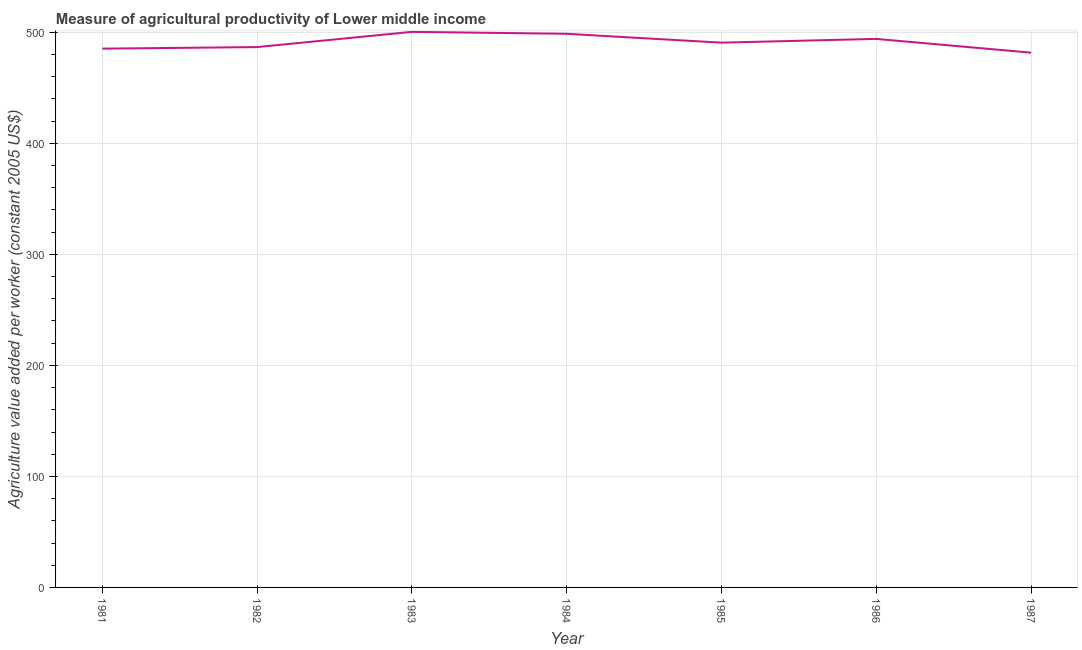What is the agriculture value added per worker in 1982?
Ensure brevity in your answer.  486.74. Across all years, what is the maximum agriculture value added per worker?
Provide a succinct answer. 500.44. Across all years, what is the minimum agriculture value added per worker?
Ensure brevity in your answer.  481.7. What is the sum of the agriculture value added per worker?
Provide a succinct answer. 3437.73. What is the difference between the agriculture value added per worker in 1984 and 1987?
Provide a short and direct response. 17. What is the average agriculture value added per worker per year?
Your answer should be compact. 491.1. What is the median agriculture value added per worker?
Provide a short and direct response. 490.72. In how many years, is the agriculture value added per worker greater than 460 US$?
Offer a terse response. 7. What is the ratio of the agriculture value added per worker in 1981 to that in 1982?
Your response must be concise. 1. Is the difference between the agriculture value added per worker in 1985 and 1987 greater than the difference between any two years?
Ensure brevity in your answer.  No. What is the difference between the highest and the second highest agriculture value added per worker?
Provide a succinct answer. 1.74. What is the difference between the highest and the lowest agriculture value added per worker?
Make the answer very short. 18.74. In how many years, is the agriculture value added per worker greater than the average agriculture value added per worker taken over all years?
Keep it short and to the point. 3. Does the agriculture value added per worker monotonically increase over the years?
Offer a terse response. No. How many lines are there?
Offer a terse response. 1. How many years are there in the graph?
Give a very brief answer. 7. What is the difference between two consecutive major ticks on the Y-axis?
Your response must be concise. 100. Does the graph contain any zero values?
Give a very brief answer. No. What is the title of the graph?
Your response must be concise. Measure of agricultural productivity of Lower middle income. What is the label or title of the X-axis?
Provide a short and direct response. Year. What is the label or title of the Y-axis?
Offer a terse response. Agriculture value added per worker (constant 2005 US$). What is the Agriculture value added per worker (constant 2005 US$) in 1981?
Provide a short and direct response. 485.33. What is the Agriculture value added per worker (constant 2005 US$) of 1982?
Provide a succinct answer. 486.74. What is the Agriculture value added per worker (constant 2005 US$) in 1983?
Your response must be concise. 500.44. What is the Agriculture value added per worker (constant 2005 US$) of 1984?
Ensure brevity in your answer.  498.7. What is the Agriculture value added per worker (constant 2005 US$) of 1985?
Your answer should be very brief. 490.72. What is the Agriculture value added per worker (constant 2005 US$) of 1986?
Offer a terse response. 494.11. What is the Agriculture value added per worker (constant 2005 US$) in 1987?
Provide a short and direct response. 481.7. What is the difference between the Agriculture value added per worker (constant 2005 US$) in 1981 and 1982?
Offer a very short reply. -1.4. What is the difference between the Agriculture value added per worker (constant 2005 US$) in 1981 and 1983?
Ensure brevity in your answer.  -15.1. What is the difference between the Agriculture value added per worker (constant 2005 US$) in 1981 and 1984?
Keep it short and to the point. -13.36. What is the difference between the Agriculture value added per worker (constant 2005 US$) in 1981 and 1985?
Provide a short and direct response. -5.38. What is the difference between the Agriculture value added per worker (constant 2005 US$) in 1981 and 1986?
Your response must be concise. -8.77. What is the difference between the Agriculture value added per worker (constant 2005 US$) in 1981 and 1987?
Your response must be concise. 3.63. What is the difference between the Agriculture value added per worker (constant 2005 US$) in 1982 and 1983?
Give a very brief answer. -13.7. What is the difference between the Agriculture value added per worker (constant 2005 US$) in 1982 and 1984?
Your response must be concise. -11.96. What is the difference between the Agriculture value added per worker (constant 2005 US$) in 1982 and 1985?
Your answer should be compact. -3.98. What is the difference between the Agriculture value added per worker (constant 2005 US$) in 1982 and 1986?
Give a very brief answer. -7.37. What is the difference between the Agriculture value added per worker (constant 2005 US$) in 1982 and 1987?
Your answer should be very brief. 5.04. What is the difference between the Agriculture value added per worker (constant 2005 US$) in 1983 and 1984?
Your response must be concise. 1.74. What is the difference between the Agriculture value added per worker (constant 2005 US$) in 1983 and 1985?
Offer a very short reply. 9.72. What is the difference between the Agriculture value added per worker (constant 2005 US$) in 1983 and 1986?
Provide a succinct answer. 6.33. What is the difference between the Agriculture value added per worker (constant 2005 US$) in 1983 and 1987?
Ensure brevity in your answer.  18.74. What is the difference between the Agriculture value added per worker (constant 2005 US$) in 1984 and 1985?
Your answer should be very brief. 7.98. What is the difference between the Agriculture value added per worker (constant 2005 US$) in 1984 and 1986?
Keep it short and to the point. 4.59. What is the difference between the Agriculture value added per worker (constant 2005 US$) in 1984 and 1987?
Your response must be concise. 17. What is the difference between the Agriculture value added per worker (constant 2005 US$) in 1985 and 1986?
Your answer should be very brief. -3.39. What is the difference between the Agriculture value added per worker (constant 2005 US$) in 1985 and 1987?
Ensure brevity in your answer.  9.02. What is the difference between the Agriculture value added per worker (constant 2005 US$) in 1986 and 1987?
Your answer should be very brief. 12.41. What is the ratio of the Agriculture value added per worker (constant 2005 US$) in 1981 to that in 1982?
Your response must be concise. 1. What is the ratio of the Agriculture value added per worker (constant 2005 US$) in 1981 to that in 1983?
Your response must be concise. 0.97. What is the ratio of the Agriculture value added per worker (constant 2005 US$) in 1981 to that in 1984?
Provide a short and direct response. 0.97. What is the ratio of the Agriculture value added per worker (constant 2005 US$) in 1981 to that in 1987?
Provide a succinct answer. 1.01. What is the ratio of the Agriculture value added per worker (constant 2005 US$) in 1982 to that in 1986?
Give a very brief answer. 0.98. What is the ratio of the Agriculture value added per worker (constant 2005 US$) in 1983 to that in 1986?
Provide a succinct answer. 1.01. What is the ratio of the Agriculture value added per worker (constant 2005 US$) in 1983 to that in 1987?
Ensure brevity in your answer.  1.04. What is the ratio of the Agriculture value added per worker (constant 2005 US$) in 1984 to that in 1985?
Offer a terse response. 1.02. What is the ratio of the Agriculture value added per worker (constant 2005 US$) in 1984 to that in 1986?
Provide a short and direct response. 1.01. What is the ratio of the Agriculture value added per worker (constant 2005 US$) in 1984 to that in 1987?
Give a very brief answer. 1.03. What is the ratio of the Agriculture value added per worker (constant 2005 US$) in 1985 to that in 1986?
Keep it short and to the point. 0.99. What is the ratio of the Agriculture value added per worker (constant 2005 US$) in 1986 to that in 1987?
Your response must be concise. 1.03. 